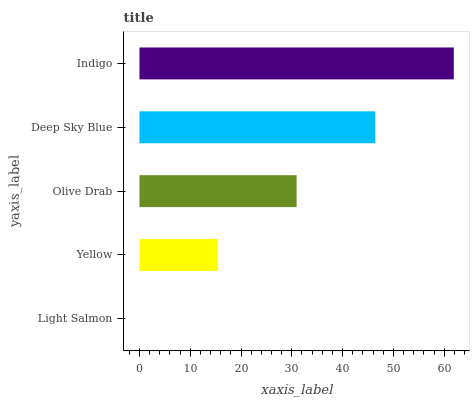Is Light Salmon the minimum?
Answer yes or no. Yes. Is Indigo the maximum?
Answer yes or no. Yes. Is Yellow the minimum?
Answer yes or no. No. Is Yellow the maximum?
Answer yes or no. No. Is Yellow greater than Light Salmon?
Answer yes or no. Yes. Is Light Salmon less than Yellow?
Answer yes or no. Yes. Is Light Salmon greater than Yellow?
Answer yes or no. No. Is Yellow less than Light Salmon?
Answer yes or no. No. Is Olive Drab the high median?
Answer yes or no. Yes. Is Olive Drab the low median?
Answer yes or no. Yes. Is Deep Sky Blue the high median?
Answer yes or no. No. Is Indigo the low median?
Answer yes or no. No. 